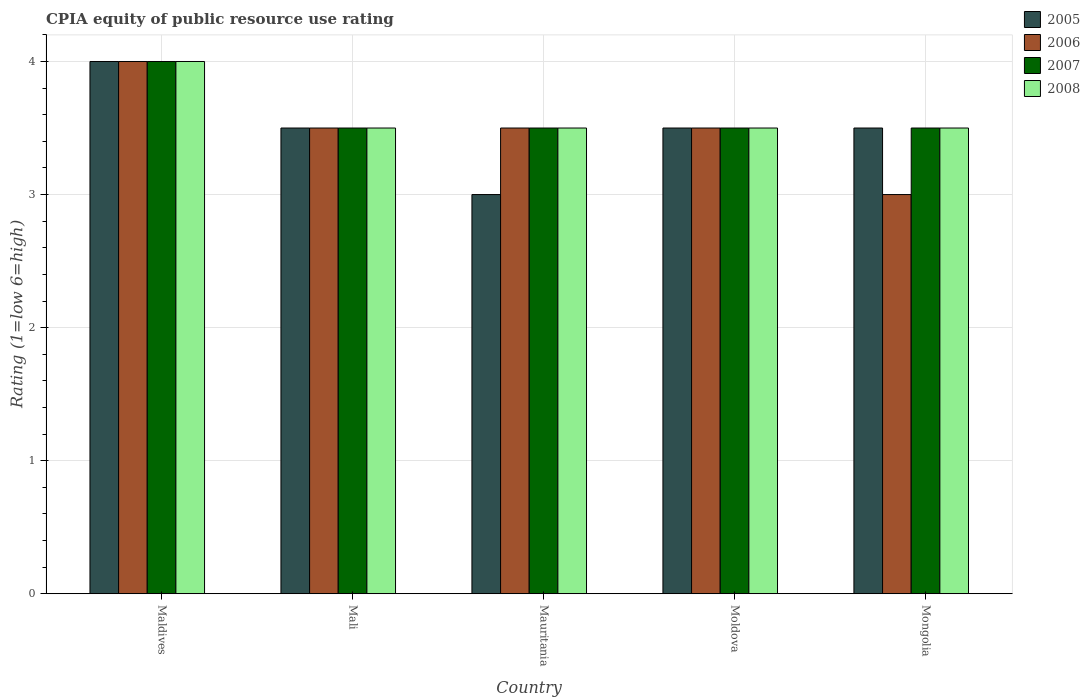How many different coloured bars are there?
Keep it short and to the point. 4. How many groups of bars are there?
Give a very brief answer. 5. Are the number of bars per tick equal to the number of legend labels?
Provide a succinct answer. Yes. How many bars are there on the 3rd tick from the left?
Keep it short and to the point. 4. How many bars are there on the 1st tick from the right?
Provide a short and direct response. 4. What is the label of the 1st group of bars from the left?
Ensure brevity in your answer.  Maldives. What is the CPIA rating in 2005 in Mauritania?
Give a very brief answer. 3. Across all countries, what is the maximum CPIA rating in 2007?
Give a very brief answer. 4. Across all countries, what is the minimum CPIA rating in 2007?
Offer a very short reply. 3.5. In which country was the CPIA rating in 2006 maximum?
Offer a very short reply. Maldives. In which country was the CPIA rating in 2005 minimum?
Your answer should be very brief. Mauritania. What is the difference between the CPIA rating in 2006 in Maldives and that in Mali?
Ensure brevity in your answer.  0.5. In how many countries, is the CPIA rating in 2007 greater than 3.8?
Provide a short and direct response. 1. Is the difference between the CPIA rating in 2007 in Mauritania and Mongolia greater than the difference between the CPIA rating in 2006 in Mauritania and Mongolia?
Provide a short and direct response. No. What is the difference between the highest and the second highest CPIA rating in 2006?
Make the answer very short. -0.5. What is the difference between the highest and the lowest CPIA rating in 2005?
Offer a terse response. 1. In how many countries, is the CPIA rating in 2005 greater than the average CPIA rating in 2005 taken over all countries?
Ensure brevity in your answer.  1. Is the sum of the CPIA rating in 2007 in Mali and Mongolia greater than the maximum CPIA rating in 2006 across all countries?
Offer a very short reply. Yes. How many bars are there?
Make the answer very short. 20. Are all the bars in the graph horizontal?
Your answer should be very brief. No. Are the values on the major ticks of Y-axis written in scientific E-notation?
Keep it short and to the point. No. Does the graph contain any zero values?
Your response must be concise. No. Where does the legend appear in the graph?
Keep it short and to the point. Top right. How many legend labels are there?
Your answer should be compact. 4. How are the legend labels stacked?
Provide a short and direct response. Vertical. What is the title of the graph?
Give a very brief answer. CPIA equity of public resource use rating. Does "1972" appear as one of the legend labels in the graph?
Ensure brevity in your answer.  No. What is the label or title of the X-axis?
Give a very brief answer. Country. What is the Rating (1=low 6=high) of 2005 in Maldives?
Your answer should be very brief. 4. What is the Rating (1=low 6=high) of 2007 in Maldives?
Keep it short and to the point. 4. What is the Rating (1=low 6=high) in 2008 in Maldives?
Ensure brevity in your answer.  4. What is the Rating (1=low 6=high) in 2006 in Mali?
Provide a succinct answer. 3.5. What is the Rating (1=low 6=high) in 2007 in Mali?
Provide a succinct answer. 3.5. What is the Rating (1=low 6=high) of 2006 in Mauritania?
Offer a very short reply. 3.5. What is the Rating (1=low 6=high) of 2008 in Mauritania?
Your response must be concise. 3.5. What is the Rating (1=low 6=high) of 2006 in Moldova?
Ensure brevity in your answer.  3.5. What is the Rating (1=low 6=high) of 2007 in Moldova?
Your response must be concise. 3.5. What is the Rating (1=low 6=high) of 2008 in Mongolia?
Make the answer very short. 3.5. Across all countries, what is the maximum Rating (1=low 6=high) in 2007?
Offer a very short reply. 4. Across all countries, what is the minimum Rating (1=low 6=high) in 2006?
Provide a succinct answer. 3. Across all countries, what is the minimum Rating (1=low 6=high) of 2007?
Offer a very short reply. 3.5. Across all countries, what is the minimum Rating (1=low 6=high) of 2008?
Ensure brevity in your answer.  3.5. What is the total Rating (1=low 6=high) in 2006 in the graph?
Offer a very short reply. 17.5. What is the total Rating (1=low 6=high) of 2008 in the graph?
Make the answer very short. 18. What is the difference between the Rating (1=low 6=high) in 2006 in Maldives and that in Mali?
Provide a short and direct response. 0.5. What is the difference between the Rating (1=low 6=high) of 2007 in Maldives and that in Mali?
Make the answer very short. 0.5. What is the difference between the Rating (1=low 6=high) of 2005 in Maldives and that in Mauritania?
Keep it short and to the point. 1. What is the difference between the Rating (1=low 6=high) of 2006 in Maldives and that in Mauritania?
Offer a very short reply. 0.5. What is the difference between the Rating (1=low 6=high) of 2007 in Maldives and that in Mauritania?
Make the answer very short. 0.5. What is the difference between the Rating (1=low 6=high) of 2005 in Maldives and that in Moldova?
Provide a short and direct response. 0.5. What is the difference between the Rating (1=low 6=high) in 2006 in Maldives and that in Mongolia?
Give a very brief answer. 1. What is the difference between the Rating (1=low 6=high) of 2007 in Maldives and that in Mongolia?
Provide a short and direct response. 0.5. What is the difference between the Rating (1=low 6=high) of 2008 in Maldives and that in Mongolia?
Make the answer very short. 0.5. What is the difference between the Rating (1=low 6=high) in 2005 in Mali and that in Mauritania?
Offer a very short reply. 0.5. What is the difference between the Rating (1=low 6=high) in 2007 in Mali and that in Moldova?
Give a very brief answer. 0. What is the difference between the Rating (1=low 6=high) of 2008 in Mali and that in Moldova?
Your response must be concise. 0. What is the difference between the Rating (1=low 6=high) of 2005 in Mali and that in Mongolia?
Ensure brevity in your answer.  0. What is the difference between the Rating (1=low 6=high) in 2007 in Mali and that in Mongolia?
Your response must be concise. 0. What is the difference between the Rating (1=low 6=high) of 2005 in Mauritania and that in Moldova?
Your response must be concise. -0.5. What is the difference between the Rating (1=low 6=high) of 2006 in Mauritania and that in Moldova?
Your answer should be very brief. 0. What is the difference between the Rating (1=low 6=high) of 2008 in Mauritania and that in Moldova?
Offer a very short reply. 0. What is the difference between the Rating (1=low 6=high) of 2005 in Mauritania and that in Mongolia?
Give a very brief answer. -0.5. What is the difference between the Rating (1=low 6=high) in 2006 in Mauritania and that in Mongolia?
Make the answer very short. 0.5. What is the difference between the Rating (1=low 6=high) in 2007 in Mauritania and that in Mongolia?
Give a very brief answer. 0. What is the difference between the Rating (1=low 6=high) in 2005 in Moldova and that in Mongolia?
Your answer should be very brief. 0. What is the difference between the Rating (1=low 6=high) in 2008 in Moldova and that in Mongolia?
Provide a short and direct response. 0. What is the difference between the Rating (1=low 6=high) in 2005 in Maldives and the Rating (1=low 6=high) in 2008 in Mali?
Provide a succinct answer. 0.5. What is the difference between the Rating (1=low 6=high) of 2006 in Maldives and the Rating (1=low 6=high) of 2007 in Mali?
Make the answer very short. 0.5. What is the difference between the Rating (1=low 6=high) of 2007 in Maldives and the Rating (1=low 6=high) of 2008 in Mali?
Provide a succinct answer. 0.5. What is the difference between the Rating (1=low 6=high) in 2005 in Maldives and the Rating (1=low 6=high) in 2007 in Mauritania?
Your answer should be very brief. 0.5. What is the difference between the Rating (1=low 6=high) of 2005 in Maldives and the Rating (1=low 6=high) of 2008 in Mauritania?
Your response must be concise. 0.5. What is the difference between the Rating (1=low 6=high) in 2006 in Maldives and the Rating (1=low 6=high) in 2007 in Mauritania?
Keep it short and to the point. 0.5. What is the difference between the Rating (1=low 6=high) in 2006 in Maldives and the Rating (1=low 6=high) in 2008 in Mauritania?
Keep it short and to the point. 0.5. What is the difference between the Rating (1=low 6=high) of 2005 in Maldives and the Rating (1=low 6=high) of 2006 in Moldova?
Provide a short and direct response. 0.5. What is the difference between the Rating (1=low 6=high) of 2005 in Maldives and the Rating (1=low 6=high) of 2008 in Moldova?
Your answer should be compact. 0.5. What is the difference between the Rating (1=low 6=high) in 2006 in Maldives and the Rating (1=low 6=high) in 2008 in Moldova?
Ensure brevity in your answer.  0.5. What is the difference between the Rating (1=low 6=high) of 2005 in Maldives and the Rating (1=low 6=high) of 2006 in Mongolia?
Offer a terse response. 1. What is the difference between the Rating (1=low 6=high) of 2005 in Maldives and the Rating (1=low 6=high) of 2008 in Mongolia?
Ensure brevity in your answer.  0.5. What is the difference between the Rating (1=low 6=high) in 2006 in Maldives and the Rating (1=low 6=high) in 2007 in Mongolia?
Your answer should be very brief. 0.5. What is the difference between the Rating (1=low 6=high) of 2006 in Maldives and the Rating (1=low 6=high) of 2008 in Mongolia?
Offer a terse response. 0.5. What is the difference between the Rating (1=low 6=high) in 2007 in Maldives and the Rating (1=low 6=high) in 2008 in Mongolia?
Your response must be concise. 0.5. What is the difference between the Rating (1=low 6=high) in 2005 in Mali and the Rating (1=low 6=high) in 2008 in Mauritania?
Keep it short and to the point. 0. What is the difference between the Rating (1=low 6=high) in 2006 in Mali and the Rating (1=low 6=high) in 2007 in Mauritania?
Offer a very short reply. 0. What is the difference between the Rating (1=low 6=high) in 2005 in Mali and the Rating (1=low 6=high) in 2007 in Moldova?
Provide a succinct answer. 0. What is the difference between the Rating (1=low 6=high) of 2005 in Mali and the Rating (1=low 6=high) of 2008 in Moldova?
Your answer should be compact. 0. What is the difference between the Rating (1=low 6=high) in 2006 in Mali and the Rating (1=low 6=high) in 2007 in Moldova?
Provide a short and direct response. 0. What is the difference between the Rating (1=low 6=high) of 2006 in Mali and the Rating (1=low 6=high) of 2008 in Moldova?
Offer a terse response. 0. What is the difference between the Rating (1=low 6=high) of 2005 in Mali and the Rating (1=low 6=high) of 2006 in Mongolia?
Offer a terse response. 0.5. What is the difference between the Rating (1=low 6=high) of 2005 in Mali and the Rating (1=low 6=high) of 2008 in Mongolia?
Provide a succinct answer. 0. What is the difference between the Rating (1=low 6=high) of 2005 in Mauritania and the Rating (1=low 6=high) of 2008 in Moldova?
Offer a very short reply. -0.5. What is the difference between the Rating (1=low 6=high) of 2006 in Mauritania and the Rating (1=low 6=high) of 2007 in Moldova?
Make the answer very short. 0. What is the difference between the Rating (1=low 6=high) of 2006 in Mauritania and the Rating (1=low 6=high) of 2008 in Moldova?
Your response must be concise. 0. What is the difference between the Rating (1=low 6=high) of 2007 in Mauritania and the Rating (1=low 6=high) of 2008 in Moldova?
Provide a short and direct response. 0. What is the difference between the Rating (1=low 6=high) in 2005 in Mauritania and the Rating (1=low 6=high) in 2006 in Mongolia?
Offer a terse response. 0. What is the difference between the Rating (1=low 6=high) in 2005 in Moldova and the Rating (1=low 6=high) in 2006 in Mongolia?
Give a very brief answer. 0.5. What is the difference between the Rating (1=low 6=high) of 2006 in Moldova and the Rating (1=low 6=high) of 2008 in Mongolia?
Give a very brief answer. 0. What is the difference between the Rating (1=low 6=high) in 2007 in Moldova and the Rating (1=low 6=high) in 2008 in Mongolia?
Your answer should be compact. 0. What is the average Rating (1=low 6=high) in 2006 per country?
Provide a succinct answer. 3.5. What is the difference between the Rating (1=low 6=high) in 2005 and Rating (1=low 6=high) in 2006 in Maldives?
Keep it short and to the point. 0. What is the difference between the Rating (1=low 6=high) in 2006 and Rating (1=low 6=high) in 2007 in Maldives?
Keep it short and to the point. 0. What is the difference between the Rating (1=low 6=high) in 2006 and Rating (1=low 6=high) in 2008 in Maldives?
Provide a short and direct response. 0. What is the difference between the Rating (1=low 6=high) in 2005 and Rating (1=low 6=high) in 2006 in Mali?
Your answer should be compact. 0. What is the difference between the Rating (1=low 6=high) in 2006 and Rating (1=low 6=high) in 2007 in Mali?
Give a very brief answer. 0. What is the difference between the Rating (1=low 6=high) in 2006 and Rating (1=low 6=high) in 2008 in Mali?
Provide a succinct answer. 0. What is the difference between the Rating (1=low 6=high) in 2007 and Rating (1=low 6=high) in 2008 in Mali?
Your answer should be compact. 0. What is the difference between the Rating (1=low 6=high) in 2005 and Rating (1=low 6=high) in 2008 in Mauritania?
Offer a terse response. -0.5. What is the difference between the Rating (1=low 6=high) in 2007 and Rating (1=low 6=high) in 2008 in Mauritania?
Offer a very short reply. 0. What is the difference between the Rating (1=low 6=high) of 2005 and Rating (1=low 6=high) of 2006 in Moldova?
Keep it short and to the point. 0. What is the difference between the Rating (1=low 6=high) in 2005 and Rating (1=low 6=high) in 2007 in Moldova?
Give a very brief answer. 0. What is the difference between the Rating (1=low 6=high) of 2005 and Rating (1=low 6=high) of 2008 in Moldova?
Offer a terse response. 0. What is the difference between the Rating (1=low 6=high) of 2006 and Rating (1=low 6=high) of 2007 in Moldova?
Your response must be concise. 0. What is the difference between the Rating (1=low 6=high) in 2005 and Rating (1=low 6=high) in 2006 in Mongolia?
Make the answer very short. 0.5. What is the difference between the Rating (1=low 6=high) in 2005 and Rating (1=low 6=high) in 2007 in Mongolia?
Your answer should be very brief. 0. What is the difference between the Rating (1=low 6=high) in 2006 and Rating (1=low 6=high) in 2007 in Mongolia?
Give a very brief answer. -0.5. What is the difference between the Rating (1=low 6=high) in 2006 and Rating (1=low 6=high) in 2008 in Mongolia?
Ensure brevity in your answer.  -0.5. What is the ratio of the Rating (1=low 6=high) of 2005 in Maldives to that in Mali?
Your answer should be very brief. 1.14. What is the ratio of the Rating (1=low 6=high) of 2005 in Maldives to that in Mauritania?
Ensure brevity in your answer.  1.33. What is the ratio of the Rating (1=low 6=high) of 2006 in Maldives to that in Mauritania?
Give a very brief answer. 1.14. What is the ratio of the Rating (1=low 6=high) in 2005 in Maldives to that in Moldova?
Your answer should be very brief. 1.14. What is the ratio of the Rating (1=low 6=high) in 2008 in Maldives to that in Moldova?
Give a very brief answer. 1.14. What is the ratio of the Rating (1=low 6=high) in 2007 in Maldives to that in Mongolia?
Provide a succinct answer. 1.14. What is the ratio of the Rating (1=low 6=high) in 2008 in Maldives to that in Mongolia?
Offer a terse response. 1.14. What is the ratio of the Rating (1=low 6=high) of 2005 in Mali to that in Mauritania?
Provide a short and direct response. 1.17. What is the ratio of the Rating (1=low 6=high) of 2006 in Mali to that in Mauritania?
Your answer should be compact. 1. What is the ratio of the Rating (1=low 6=high) of 2007 in Mali to that in Mauritania?
Make the answer very short. 1. What is the ratio of the Rating (1=low 6=high) in 2008 in Mali to that in Moldova?
Your response must be concise. 1. What is the ratio of the Rating (1=low 6=high) in 2005 in Mali to that in Mongolia?
Offer a terse response. 1. What is the ratio of the Rating (1=low 6=high) of 2007 in Mali to that in Mongolia?
Your answer should be very brief. 1. What is the ratio of the Rating (1=low 6=high) in 2005 in Mauritania to that in Moldova?
Your answer should be compact. 0.86. What is the ratio of the Rating (1=low 6=high) of 2006 in Mauritania to that in Moldova?
Your answer should be very brief. 1. What is the ratio of the Rating (1=low 6=high) in 2007 in Mauritania to that in Moldova?
Keep it short and to the point. 1. What is the ratio of the Rating (1=low 6=high) of 2007 in Mauritania to that in Mongolia?
Offer a very short reply. 1. What is the ratio of the Rating (1=low 6=high) of 2005 in Moldova to that in Mongolia?
Give a very brief answer. 1. What is the ratio of the Rating (1=low 6=high) of 2007 in Moldova to that in Mongolia?
Provide a short and direct response. 1. What is the difference between the highest and the lowest Rating (1=low 6=high) in 2006?
Your answer should be compact. 1. What is the difference between the highest and the lowest Rating (1=low 6=high) in 2008?
Make the answer very short. 0.5. 